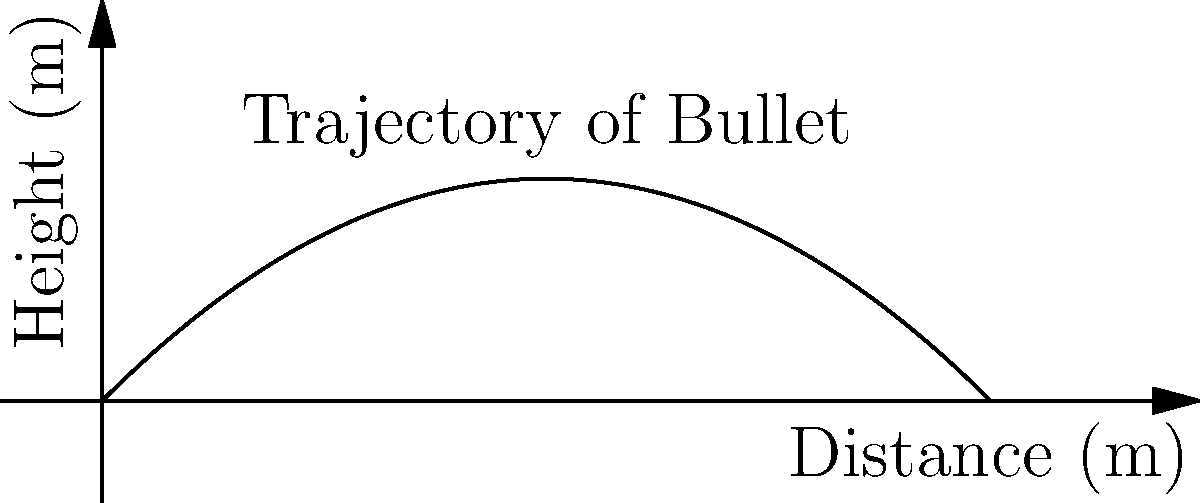In a crime scene reconstruction, a forensic analyst needs to determine the initial velocity of a bullet fired from a handgun. The bullet's trajectory follows a parabolic path, reaching a maximum height of 127.55 meters before striking a target 1020.41 meters away. Assuming the gun was fired horizontally and neglecting air resistance, what was the initial velocity of the bullet? Let's approach this step-by-step:

1) For a projectile launched horizontally, we can use the following equations:
   
   Horizontal distance: $x = v_0t$
   Vertical distance: $y = -\frac{1}{2}gt^2$

   Where $v_0$ is the initial velocity, $t$ is the time of flight, and $g$ is the acceleration due to gravity (9.8 m/s²).

2) We know the maximum height ($y_{max}$) is 127.55 m and the horizontal distance ($x$) is 1020.41 m.

3) At the maximum height, the time taken is half of the total flight time. So, if we call the total flight time $T$:

   $127.55 = -\frac{1}{2}g(\frac{T}{2})^2$

4) Solving for $T$:

   $T = 2\sqrt{\frac{2(127.55)}{g}} = 10.2$ seconds

5) Now that we know the time of flight, we can use the horizontal distance equation to find the initial velocity:

   $1020.41 = v_0(10.2)$

6) Solving for $v_0$:

   $v_0 = \frac{1020.41}{10.2} = 100$ m/s

Therefore, the initial velocity of the bullet was 100 m/s.
Answer: 100 m/s 